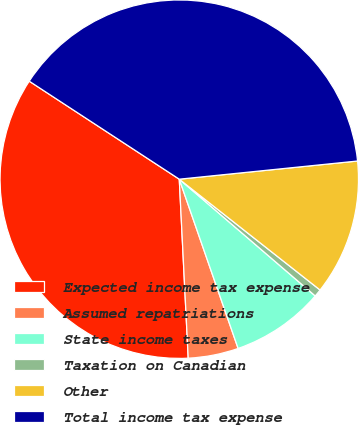<chart> <loc_0><loc_0><loc_500><loc_500><pie_chart><fcel>Expected income tax expense<fcel>Assumed repatriations<fcel>State income taxes<fcel>Taxation on Canadian<fcel>Other<fcel>Total income tax expense<nl><fcel>35.0%<fcel>4.53%<fcel>8.38%<fcel>0.68%<fcel>12.23%<fcel>39.17%<nl></chart> 